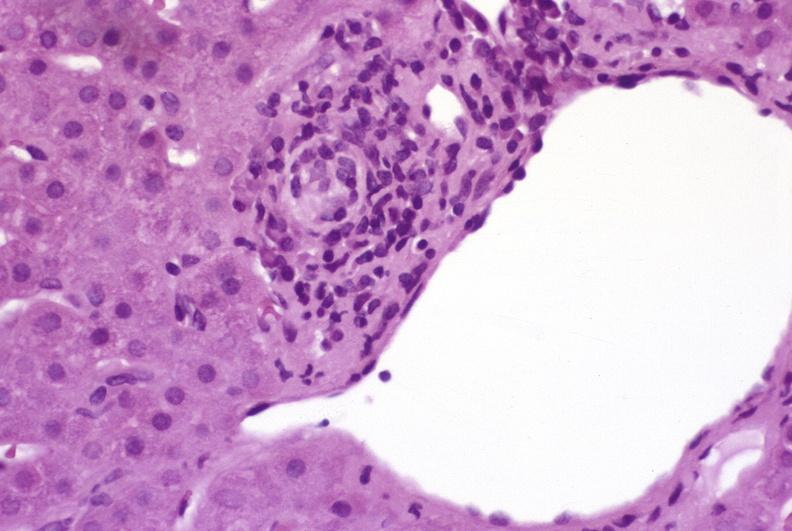s granulomata slide present?
Answer the question using a single word or phrase. No 